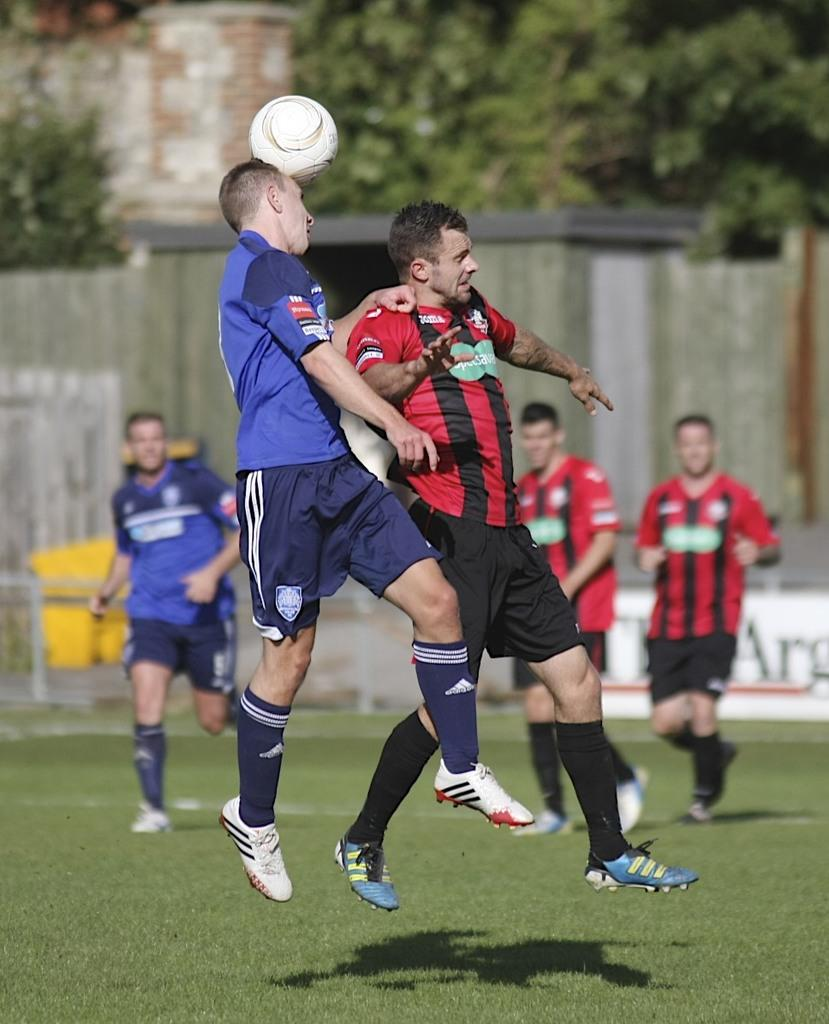What type of surface is visible on the ground in the image? There is grass on the ground in the image. What activity are the people engaged in? The people are playing football in the image. What type of material is used to construct the walls in the background? The walls in the background are made of bricks. Can you tell me what the secretary is doing in the image? There is no secretary present in the image. What type of animal can be seen playing football with the people in the image? There are no animals present in the image; only people are playing football. 